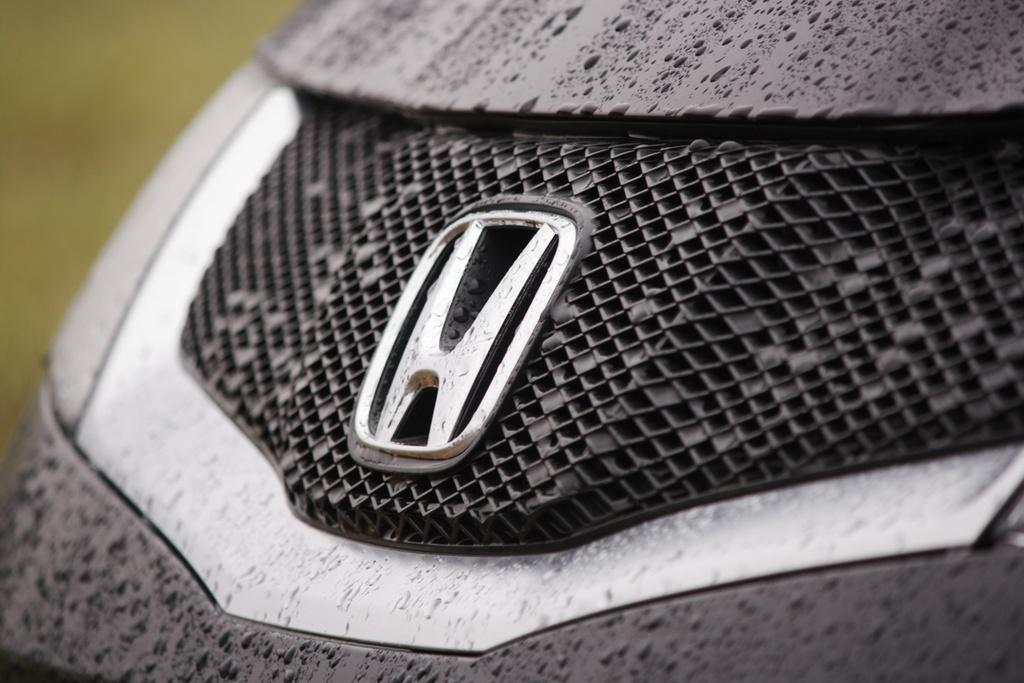What is present on the vehicle in the image? There is a logo on the vehicle. What can be seen on the surface of the vehicle? There are water droplets on the vehicle. How would you describe the background of the image? The background of the image is blurry. What type of request can be seen written on the grape in the image? There is no grape present in the image, and therefore no request can be seen written on it. 